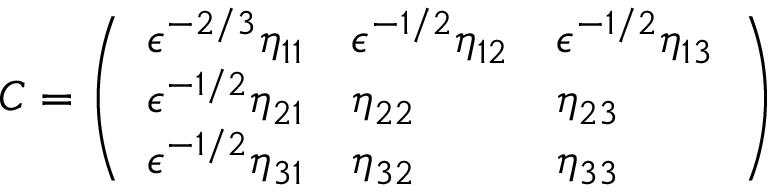Convert formula to latex. <formula><loc_0><loc_0><loc_500><loc_500>C = \left ( \begin{array} { l l l } { \epsilon ^ { - 2 / 3 } \eta _ { 1 1 } } & { \epsilon ^ { - 1 / 2 } \eta _ { 1 2 } } & { \epsilon ^ { - 1 / 2 } \eta _ { 1 3 } } \\ { \epsilon ^ { - 1 / 2 } \eta _ { 2 1 } } & { \eta _ { 2 2 } } & { \eta _ { 2 3 } } \\ { \epsilon ^ { - 1 / 2 } \eta _ { 3 1 } } & { \eta _ { 3 2 } } & { \eta _ { 3 3 } } \end{array} \right )</formula> 